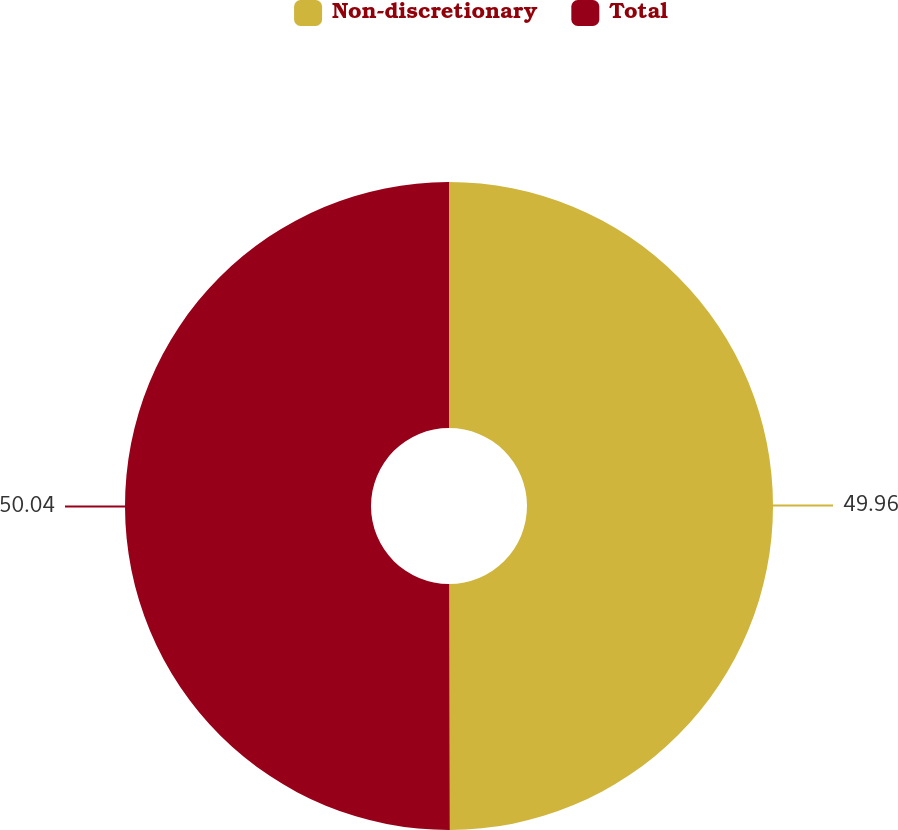Convert chart. <chart><loc_0><loc_0><loc_500><loc_500><pie_chart><fcel>Non-discretionary<fcel>Total<nl><fcel>49.96%<fcel>50.04%<nl></chart> 